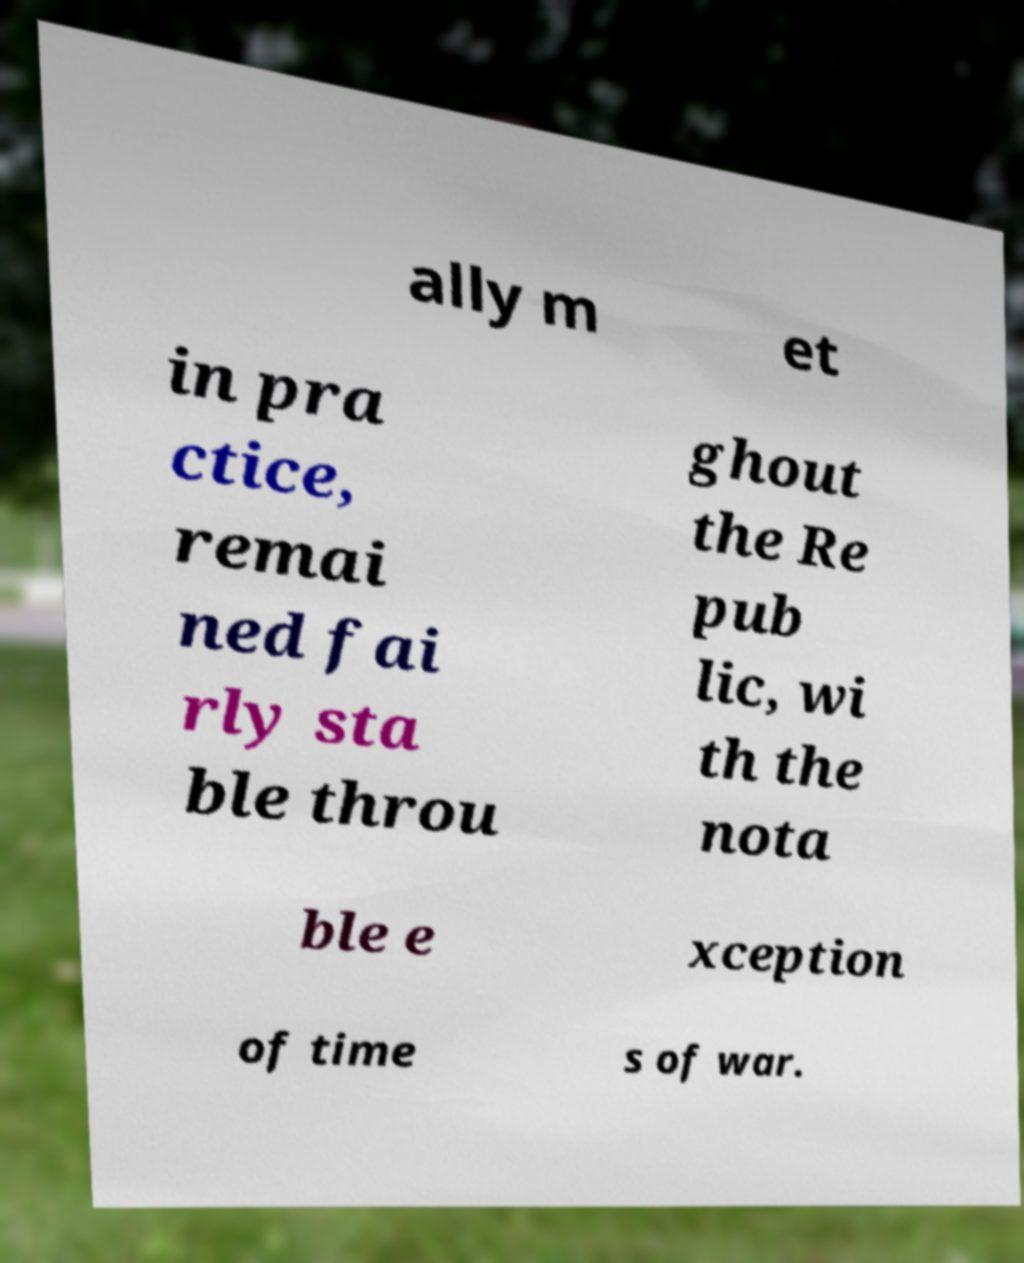I need the written content from this picture converted into text. Can you do that? ally m et in pra ctice, remai ned fai rly sta ble throu ghout the Re pub lic, wi th the nota ble e xception of time s of war. 